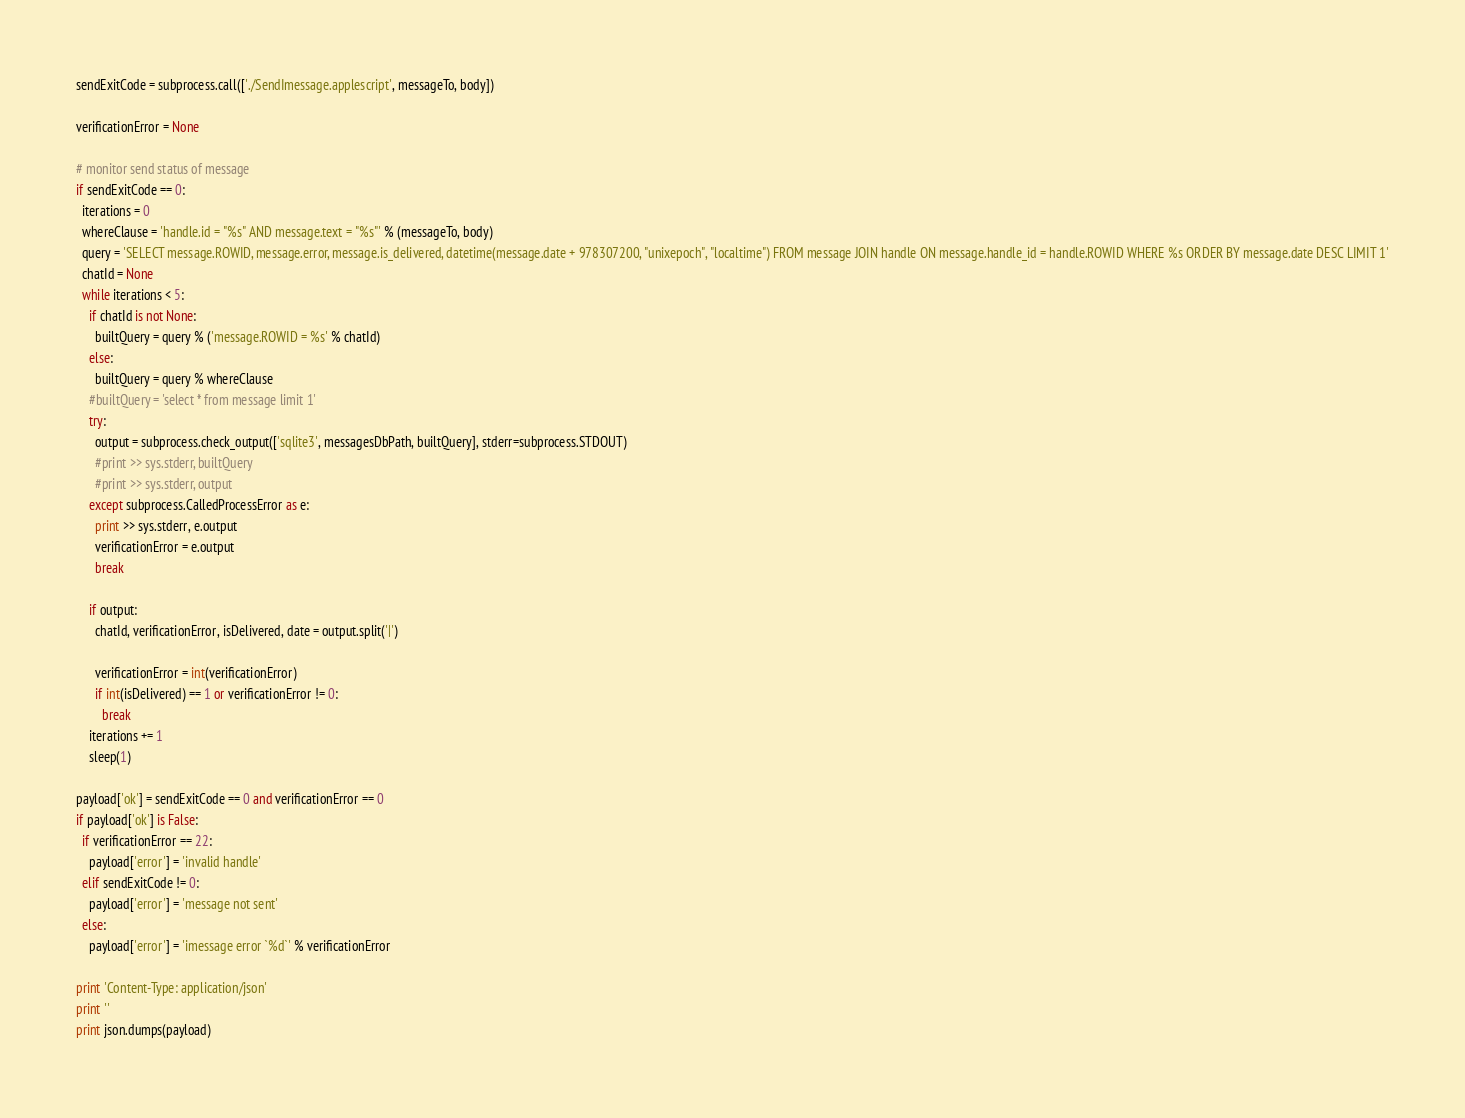Convert code to text. <code><loc_0><loc_0><loc_500><loc_500><_Python_>sendExitCode = subprocess.call(['./SendImessage.applescript', messageTo, body])

verificationError = None

# monitor send status of message
if sendExitCode == 0:
  iterations = 0
  whereClause = 'handle.id = "%s" AND message.text = "%s"' % (messageTo, body)
  query = 'SELECT message.ROWID, message.error, message.is_delivered, datetime(message.date + 978307200, "unixepoch", "localtime") FROM message JOIN handle ON message.handle_id = handle.ROWID WHERE %s ORDER BY message.date DESC LIMIT 1'
  chatId = None
  while iterations < 5:
    if chatId is not None:
      builtQuery = query % ('message.ROWID = %s' % chatId)
    else:
      builtQuery = query % whereClause
    #builtQuery = 'select * from message limit 1'
    try:
      output = subprocess.check_output(['sqlite3', messagesDbPath, builtQuery], stderr=subprocess.STDOUT)
      #print >> sys.stderr, builtQuery
      #print >> sys.stderr, output
    except subprocess.CalledProcessError as e:
      print >> sys.stderr, e.output
      verificationError = e.output
      break

    if output:
      chatId, verificationError, isDelivered, date = output.split('|')

      verificationError = int(verificationError)
      if int(isDelivered) == 1 or verificationError != 0:
        break
    iterations += 1
    sleep(1)

payload['ok'] = sendExitCode == 0 and verificationError == 0
if payload['ok'] is False:
  if verificationError == 22:
    payload['error'] = 'invalid handle'
  elif sendExitCode != 0:
    payload['error'] = 'message not sent'
  else:
    payload['error'] = 'imessage error `%d`' % verificationError

print 'Content-Type: application/json'
print ''
print json.dumps(payload)
</code> 